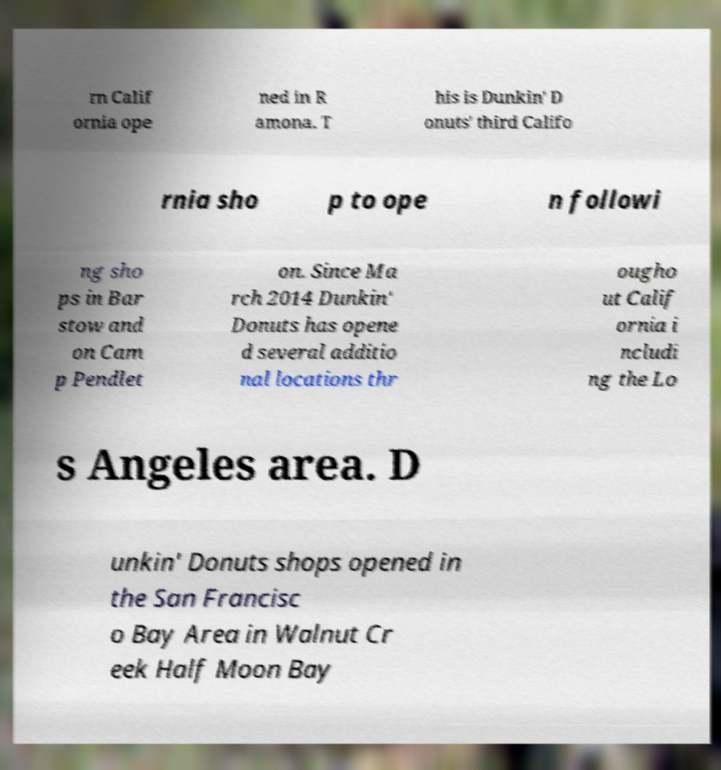There's text embedded in this image that I need extracted. Can you transcribe it verbatim? rn Calif ornia ope ned in R amona. T his is Dunkin' D onuts' third Califo rnia sho p to ope n followi ng sho ps in Bar stow and on Cam p Pendlet on. Since Ma rch 2014 Dunkin' Donuts has opene d several additio nal locations thr ougho ut Calif ornia i ncludi ng the Lo s Angeles area. D unkin' Donuts shops opened in the San Francisc o Bay Area in Walnut Cr eek Half Moon Bay 